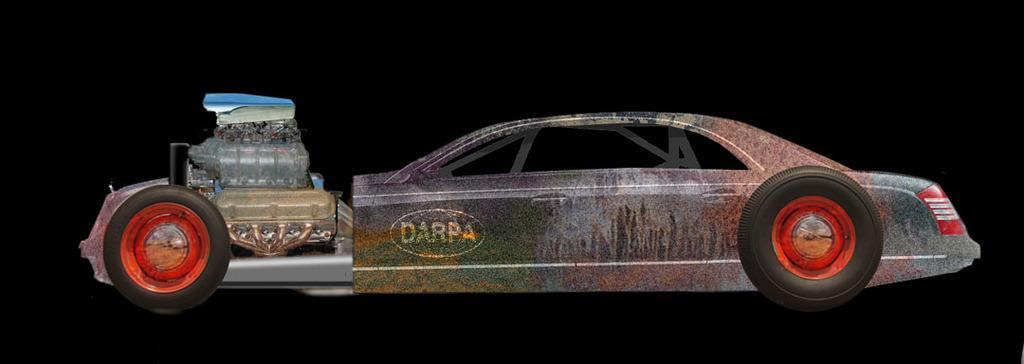Please provide a concise description of this image. In this image we can see a toy vehicle and the background it is dark. 